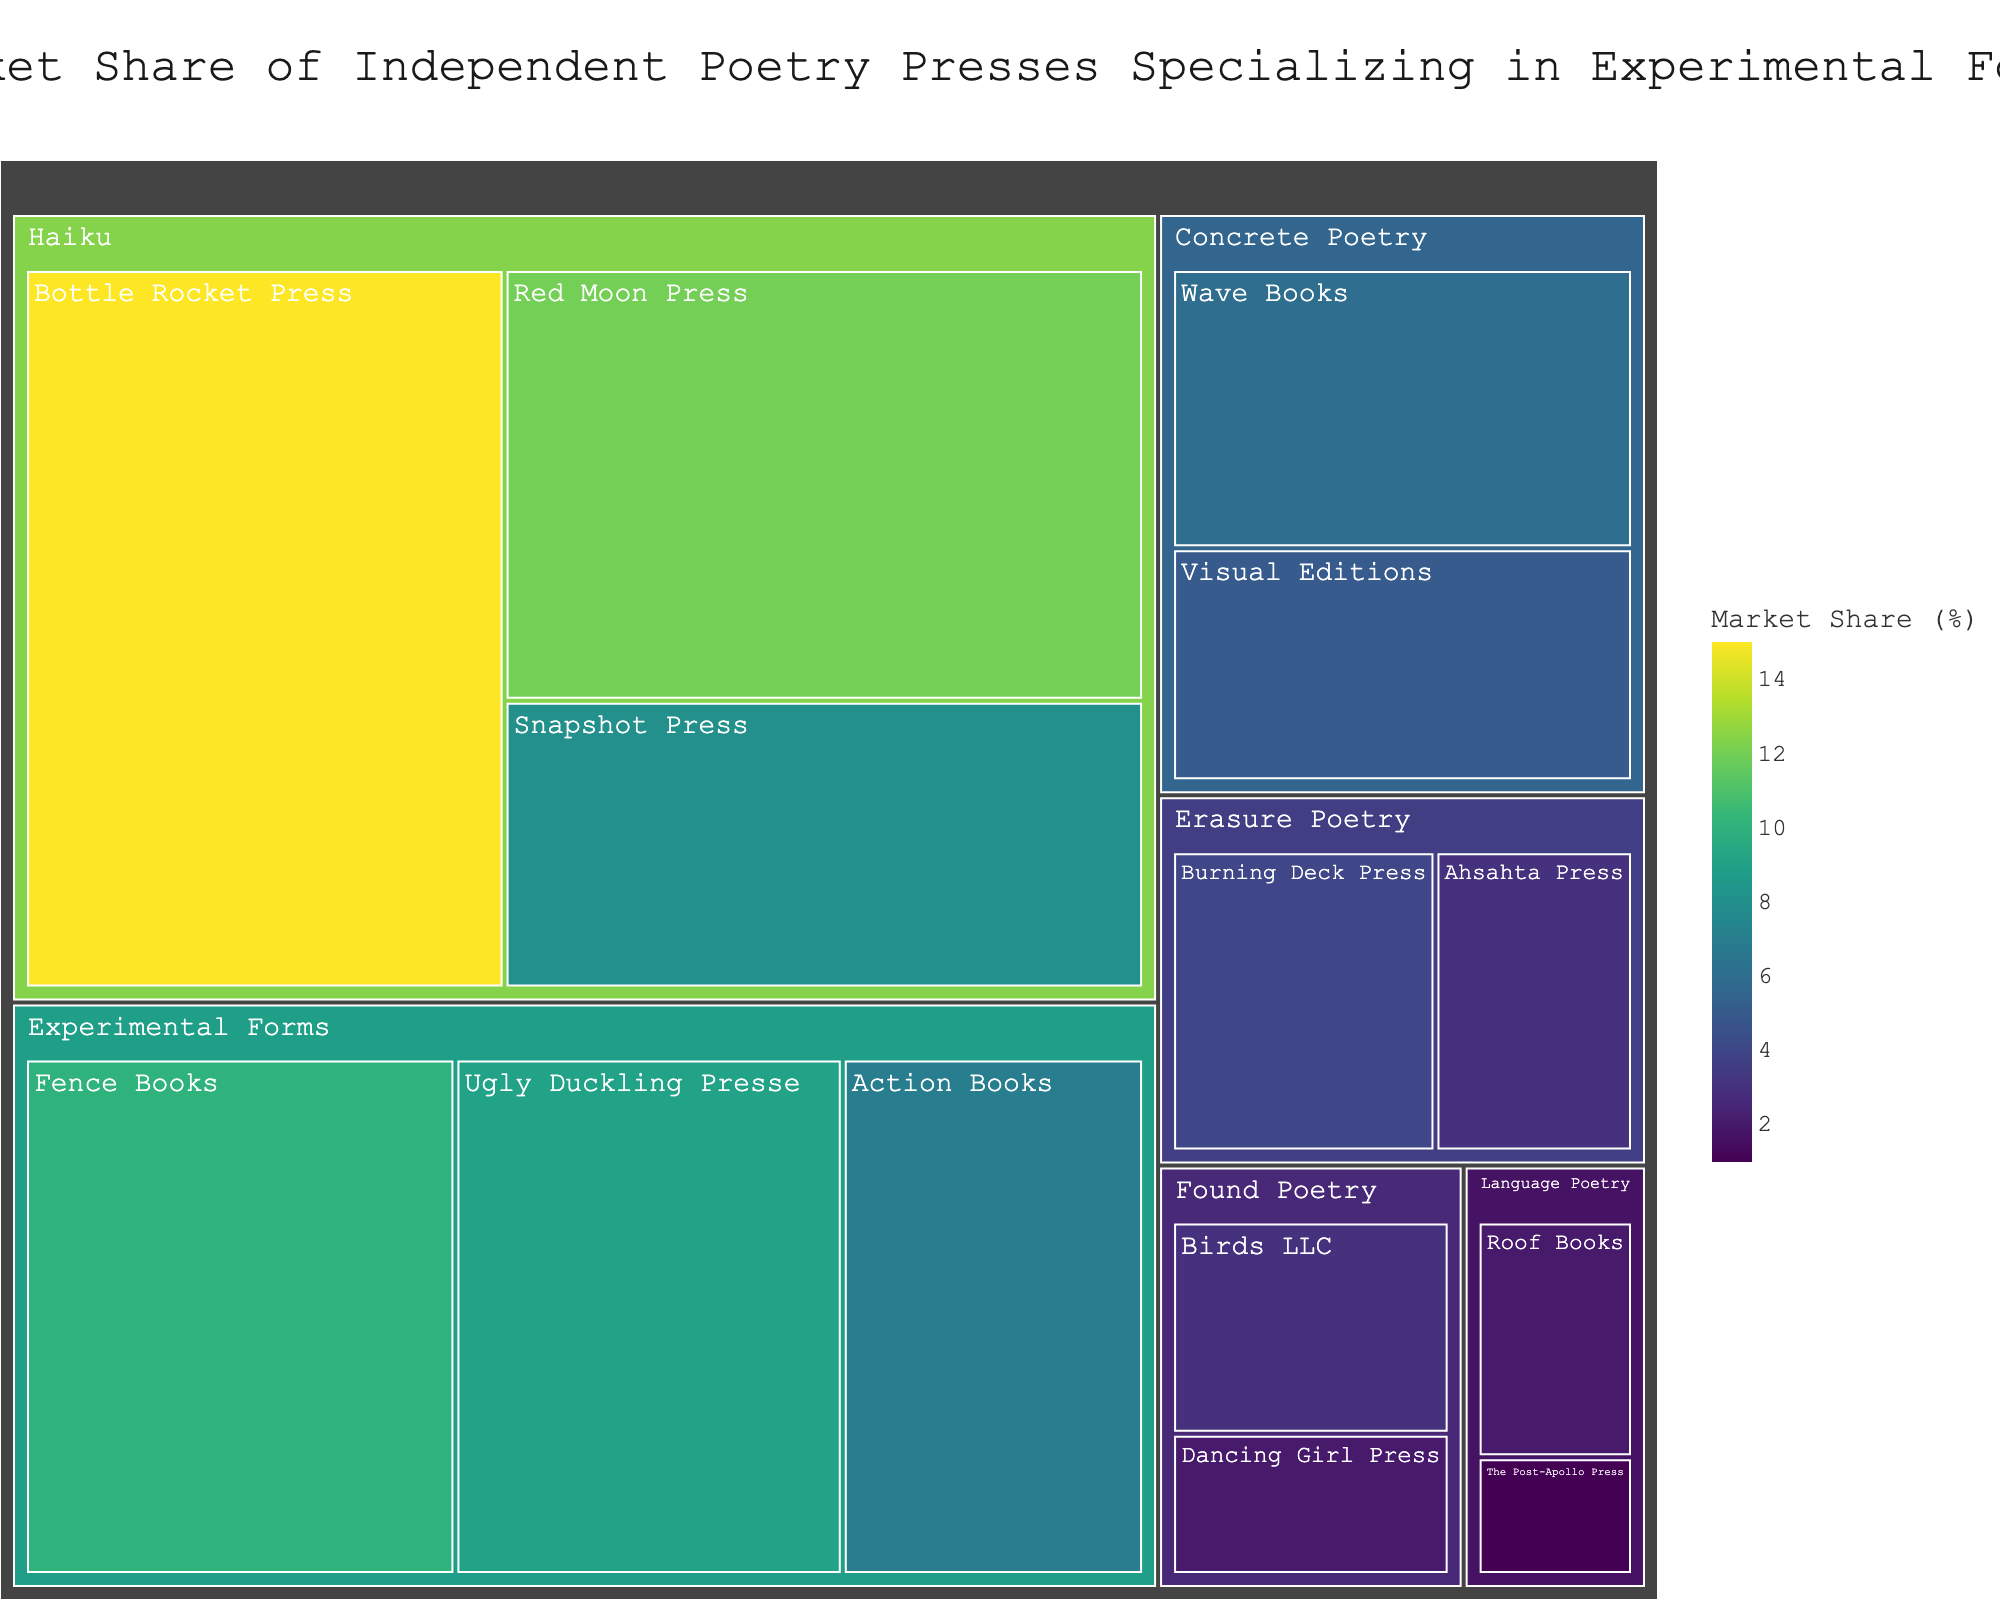What is the title of the treemap? The title of the treemap is located at the top center of the figure. It reads "Market Share of Independent Poetry Presses Specializing in Experimental Forms".
Answer: Market Share of Independent Poetry Presses Specializing in Experimental Forms Which publisher has the largest market share in the Haiku category? The treemap shows the size and color intensity of the boxes corresponding to each publisher's market share. For Haiku, Bottle Rocket Press has the largest box with a 15% market share.
Answer: Bottle Rocket Press How many publishers are there in the Found Poetry category? In the treemap, under the Found Poetry category, there are two boxes labeled Birds LLC and Dancing Girl Press. Thus, there are 2 publishers.
Answer: 2 What is the total market share of the publishers in the Concrete Poetry category? The sum of the market shares of Wave Books (6%) and Visual Editions (5%) in the Concrete Poetry category needs to be calculated. 6 + 5 equals 11.
Answer: 11% Which poetry category has the smallest market share from a single publisher and what is that market share? By looking at the individual boxes within each category, the smallest single market share is from The Post-Apollo Press in Language Poetry, at 1%.
Answer: Language Poetry, 1% Which publisher has a 10% market share and in which category do they belong? The treemap shows a 10% market share for Fence Books. The box for Fence Books falls under the Experimental Forms category.
Answer: Fence Books, Experimental Forms How does the market share of Snapshot Press compare to Visual Editions? Snapshot Press has a market share of 8% in the Haiku category, while Visual Editions has a 5% market share in the Concrete Poetry category. Therefore, Snapshot Press has a greater market share.
Answer: Snapshot Press has a greater market share What is the combined market share of all publishers in the Erasure Poetry category? Adding the market shares in Erasure Poetry: Burning Deck Press (4%) and Ahsahta Press (3%) gives a total of 4 + 3 = 7.
Answer: 7% Which category has the highest total market share and what is that total? Summing the market shares in each category: Haiku (15+12+8=35%), Experimental Forms (10+9+7=26%), Concrete Poetry (6+5=11%), Erasure Poetry (4+3=7%), Found Poetry (3+2=5%), and Language Poetry (2+1=3%). The Haiku category has the highest total market share, 35%.
Answer: Haiku, 35% What is the average market share of the publishers in the Experimental Forms category? The Experimental Forms category has three publishers with market shares of 10%, 9%, and 7%. The average is calculated as (10 + 9 + 7) / 3 = 8.67%.
Answer: 8.67% 